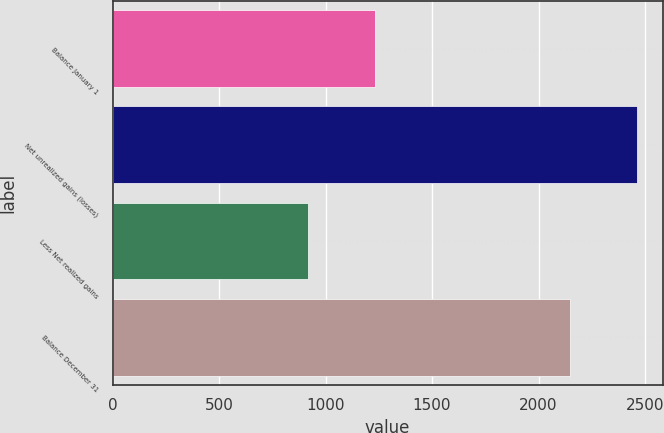Convert chart. <chart><loc_0><loc_0><loc_500><loc_500><bar_chart><fcel>Balance January 1<fcel>Net unrealized gains (losses)<fcel>Less Net realized gains<fcel>Balance December 31<nl><fcel>1232<fcel>2460<fcel>920<fcel>2148<nl></chart> 